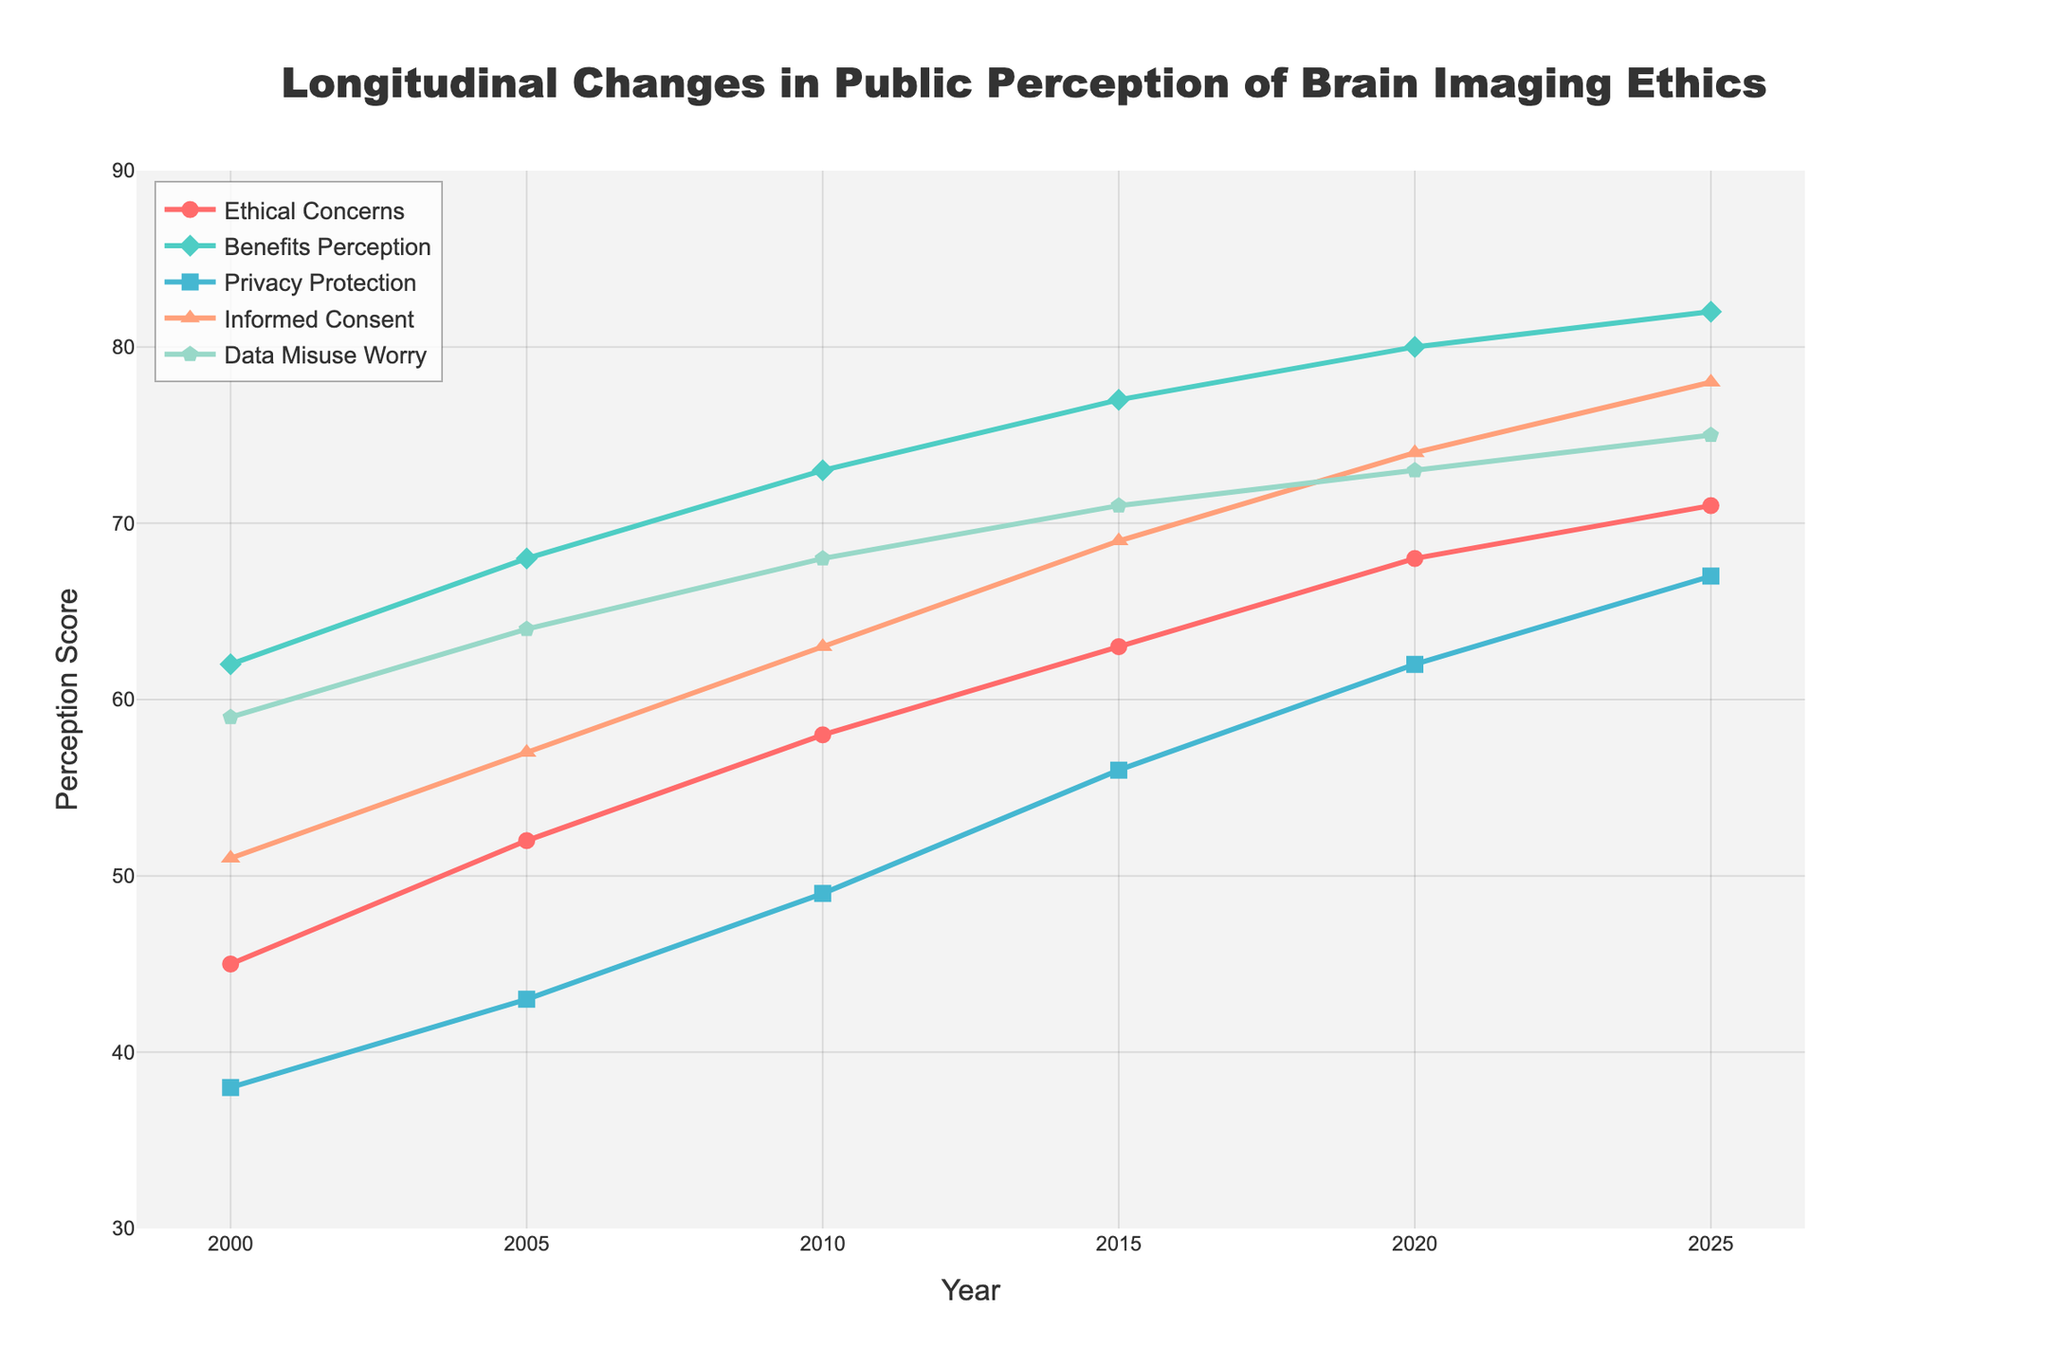what is the difference in the perception of 'Ethical Concerns' between 2000 and 2025? To determine the difference in the perception of 'Ethical Concerns' between 2000 and 2025, we subtract the 'Ethical Concerns' value in 2000 (45) from the 'Ethical Concerns' value in 2025 (71). 71 - 45 = 26
Answer: 26 Which year has the highest 'Benefits Perception'? We look at the 'Benefits Perception' values across all years and identify the highest value, which is in the year 2025 with a score of 82
Answer: 2025 Is 'Informed Consent' score higher than 'Privacy Protection' score in 2015? In 2015, the 'Informed Consent' score is 69, and the 'Privacy Protection' score is 56. Since 69 is greater than 56, 'Informed Consent' is higher than 'Privacy Protection' in that year
Answer: Yes Which factor had the greatest increase from year 2000 to 2025? To find the factor with the greatest increase, calculate the difference for each factor between 2000 and 2025 and compare. 'Ethical Concerns' increased by 26 (71 - 45), 'Benefits Perception' by 20 (82 - 62), 'Privacy Protection' by 29 (67 - 38), 'Informed Consent' by 27 (78 - 51), and 'Data Misuse Worry' by 16 (75 - 59). The greatest increase is in 'Privacy Protection' with 29
Answer: Privacy Protection Which factor had the smallest change between 2015 and 2020? Calculate the change for each factor between 2015 and 2020:'Ethical Concerns' increased by 5 (68 - 63), 'Benefits Perception' by 3 (80 - 77), 'Privacy Protection' by 6 (62 - 56), 'Informed Consent' by 5 (74 - 69), and 'Data Misuse Worry' by 2 (73 - 71). The smallest change is in 'Data Misuse Worry' with an increase of 2
Answer: Data Misuse Worry What was the average score of 'Privacy Protection' over the six years provided? To find the average 'Privacy Protection' score, sum the scores from 2000 to 2025 and divide by the number of data points. (38 + 43 + 49 + 56 + 62 + 67) / 6 = 52.5
Answer: 52.5 Between 2000 and 2025, which year shows the highest increase for 'Informed Consent' compared to the previous year? Calculate the year-over-year increase for 'Informed Consent':
2005: 57 - 51 = 6
2010: 63 - 57 = 6
2015: 69 - 63 = 6
2020: 74 - 69 = 5
2025: 78 - 74 = 4
The highest increase of 6 points occurred between 2000 and 2005, 2005 and 2010, and 2010 and 2015
Answer: 2005, 2010, 2015 How did the perception of 'Data Misuse Worry' change from 2000 to 2020? Subtract the 'Data Misuse Worry' score in 2000 (59) from the score in 2020 (73) to find the change. The change is 73 - 59 = 14
Answer: 14 Which factor consistently increased every year? By examining the scores for each factor, note which factors have higher values each subsequent year. 'Ethical Concerns', 'Benefits Perception', 'Privacy Protection', 'Informed Consent', and 'Data Misuse Worry' all show consistent increases, but the most consistent increases without fluctuation across all intervals belongs to 'Ethical Concerns'
Answer: Ethical Concerns 